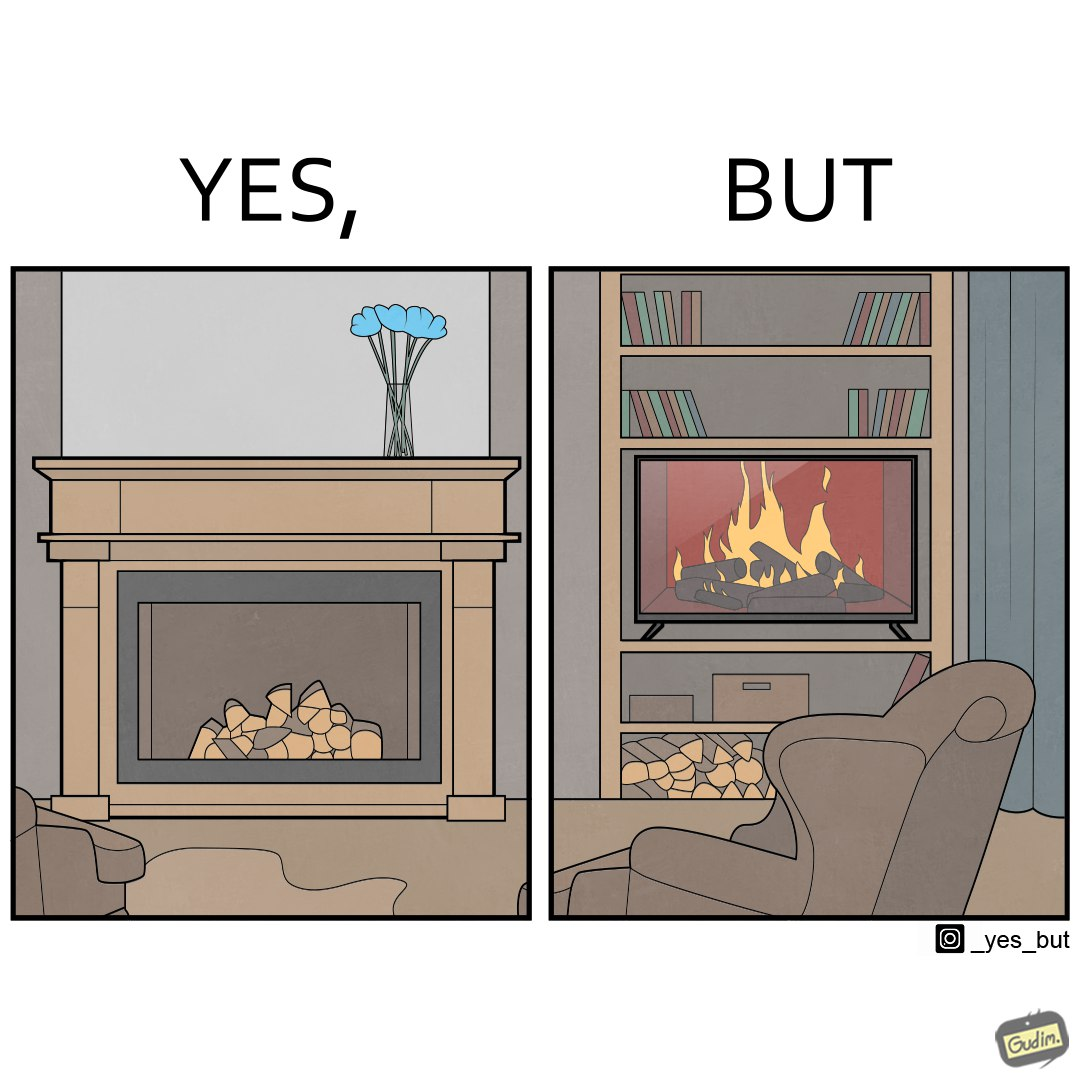Compare the left and right sides of this image. In the left part of the image: It is a fireplace In the right part of the image: It a fireplace being displayed on a television screen 